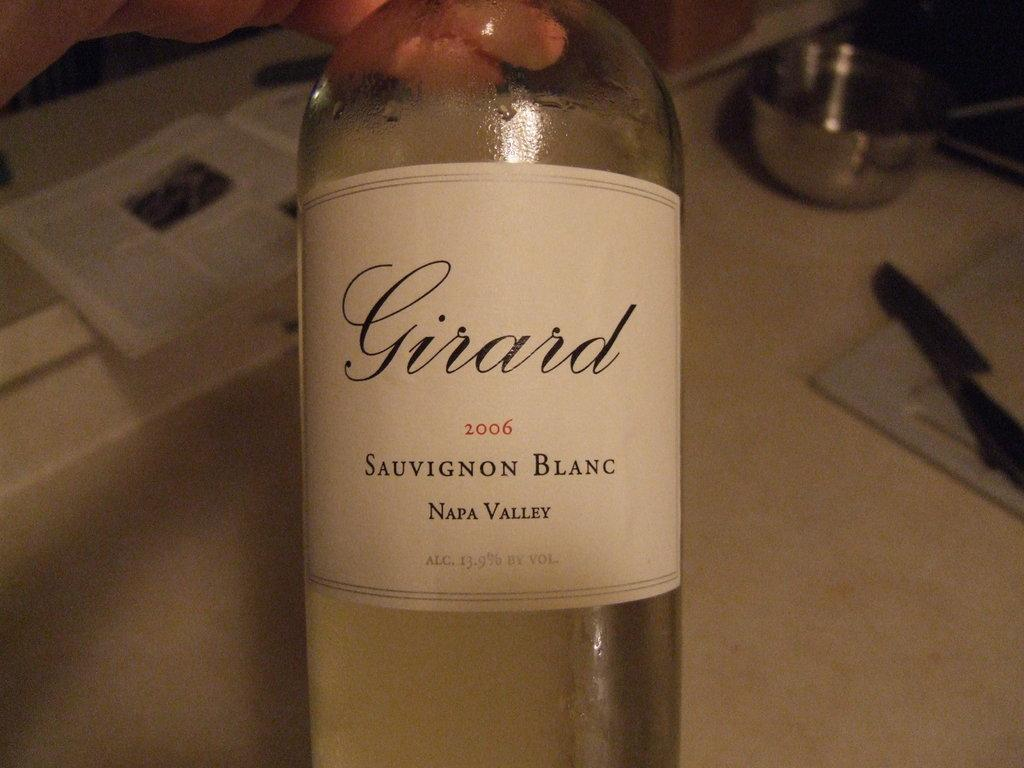What type of bottle is visible in the image? There is a bottle of girard in the image. What can be seen on the left side of the image? There is a book on the left side of the image. What is located on the right side of the image? There is kitchenware on the right side of the image. What riddle does the uncle tell in the image? There is no uncle or riddle present in the image. How does the kitchenware relate to space in the image? The image does not depict any space-related content, and the kitchenware is not associated with space. 